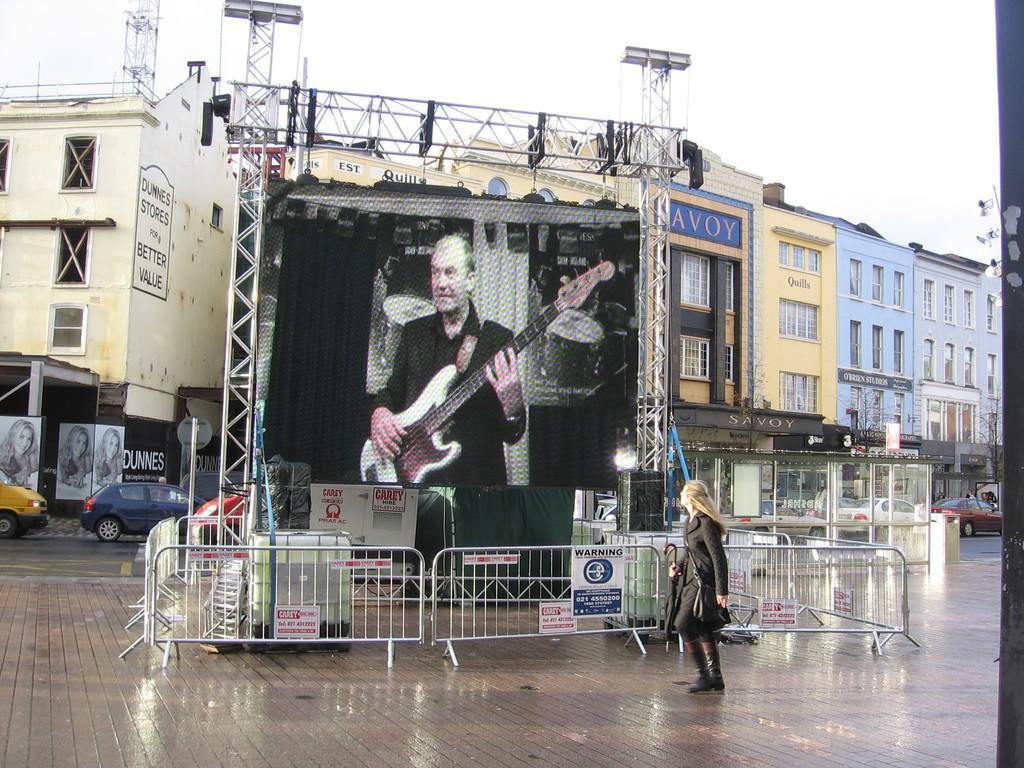How would you summarize this image in a sentence or two? In this picture we can see a woman, she wore a bag and she is walking, beside to her we can see few metal rods, speaker and a projector screen, in the background we can see few vehicles, hoardings and buildings. 